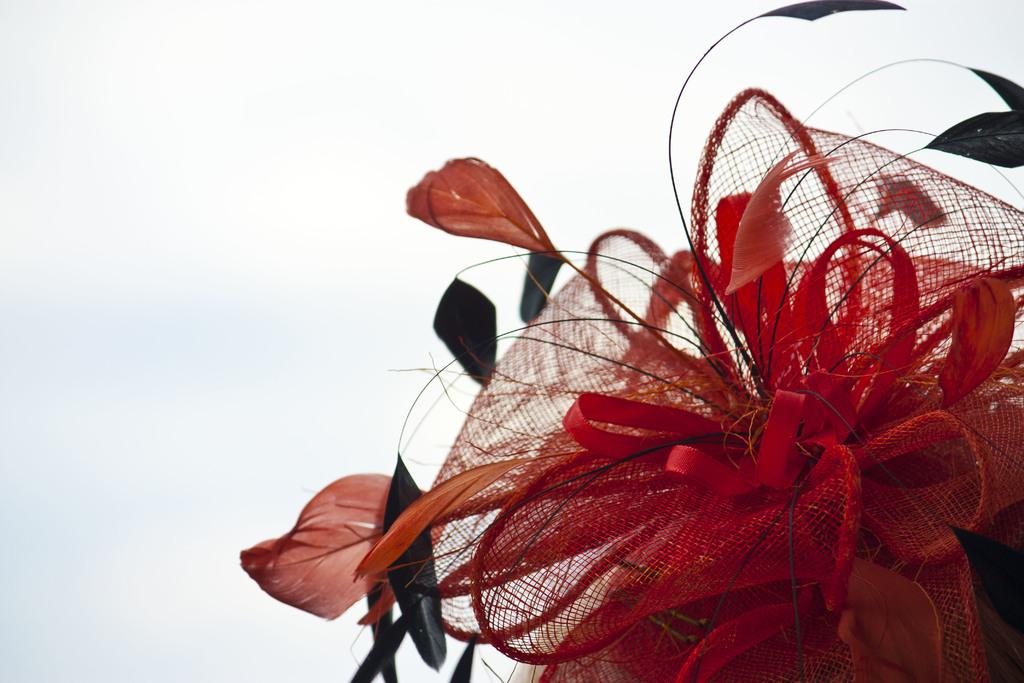What is the main object in the image made of? The main object in the image is made of red-colored net. What color is the background of the image? The background of the image is white. How many copies of the creator are visible in the image? There is no creator or copy present in the image, as it only features an object made of red-colored net against a white background. 